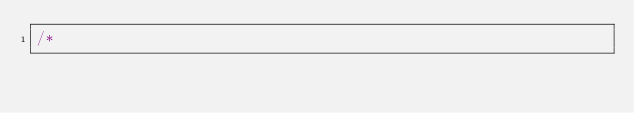Convert code to text. <code><loc_0><loc_0><loc_500><loc_500><_C_>/*</code> 